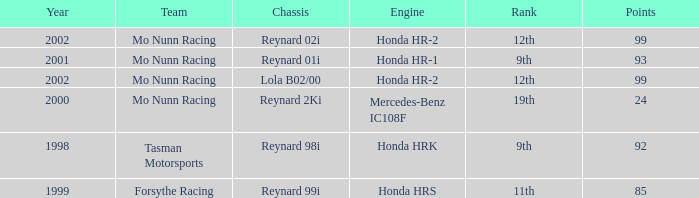What is the total number of points of the honda hr-1 engine? 1.0. Could you parse the entire table? {'header': ['Year', 'Team', 'Chassis', 'Engine', 'Rank', 'Points'], 'rows': [['2002', 'Mo Nunn Racing', 'Reynard 02i', 'Honda HR-2', '12th', '99'], ['2001', 'Mo Nunn Racing', 'Reynard 01i', 'Honda HR-1', '9th', '93'], ['2002', 'Mo Nunn Racing', 'Lola B02/00', 'Honda HR-2', '12th', '99'], ['2000', 'Mo Nunn Racing', 'Reynard 2Ki', 'Mercedes-Benz IC108F', '19th', '24'], ['1998', 'Tasman Motorsports', 'Reynard 98i', 'Honda HRK', '9th', '92'], ['1999', 'Forsythe Racing', 'Reynard 99i', 'Honda HRS', '11th', '85']]} 